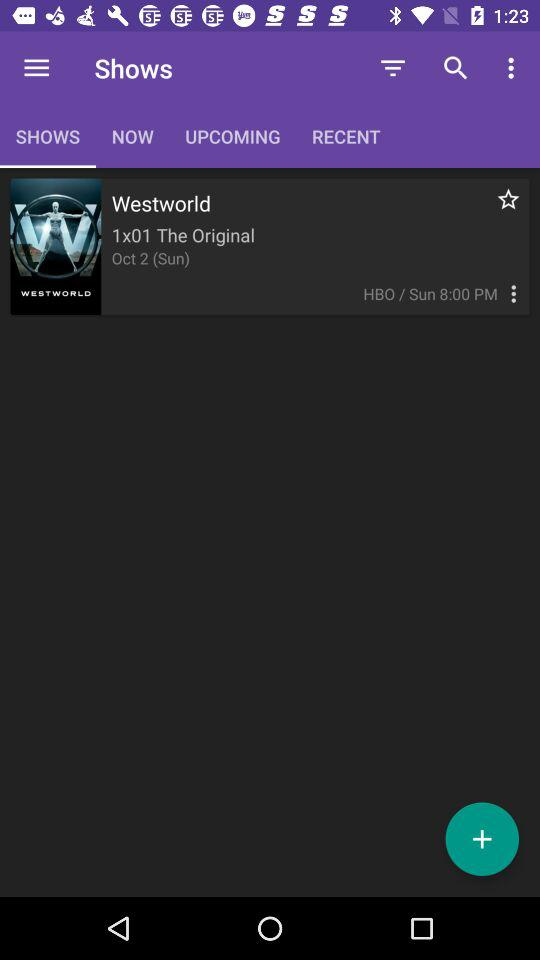What is the name of the show? The name of the show is "Westworld". 